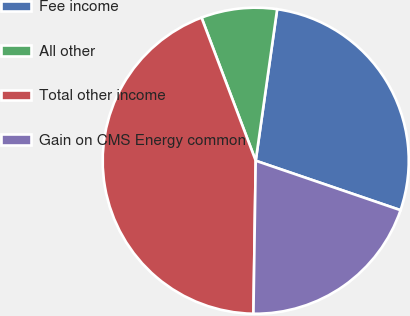Convert chart to OTSL. <chart><loc_0><loc_0><loc_500><loc_500><pie_chart><fcel>Fee income<fcel>All other<fcel>Total other income<fcel>Gain on CMS Energy common<nl><fcel>28.0%<fcel>8.0%<fcel>44.0%<fcel>20.0%<nl></chart> 